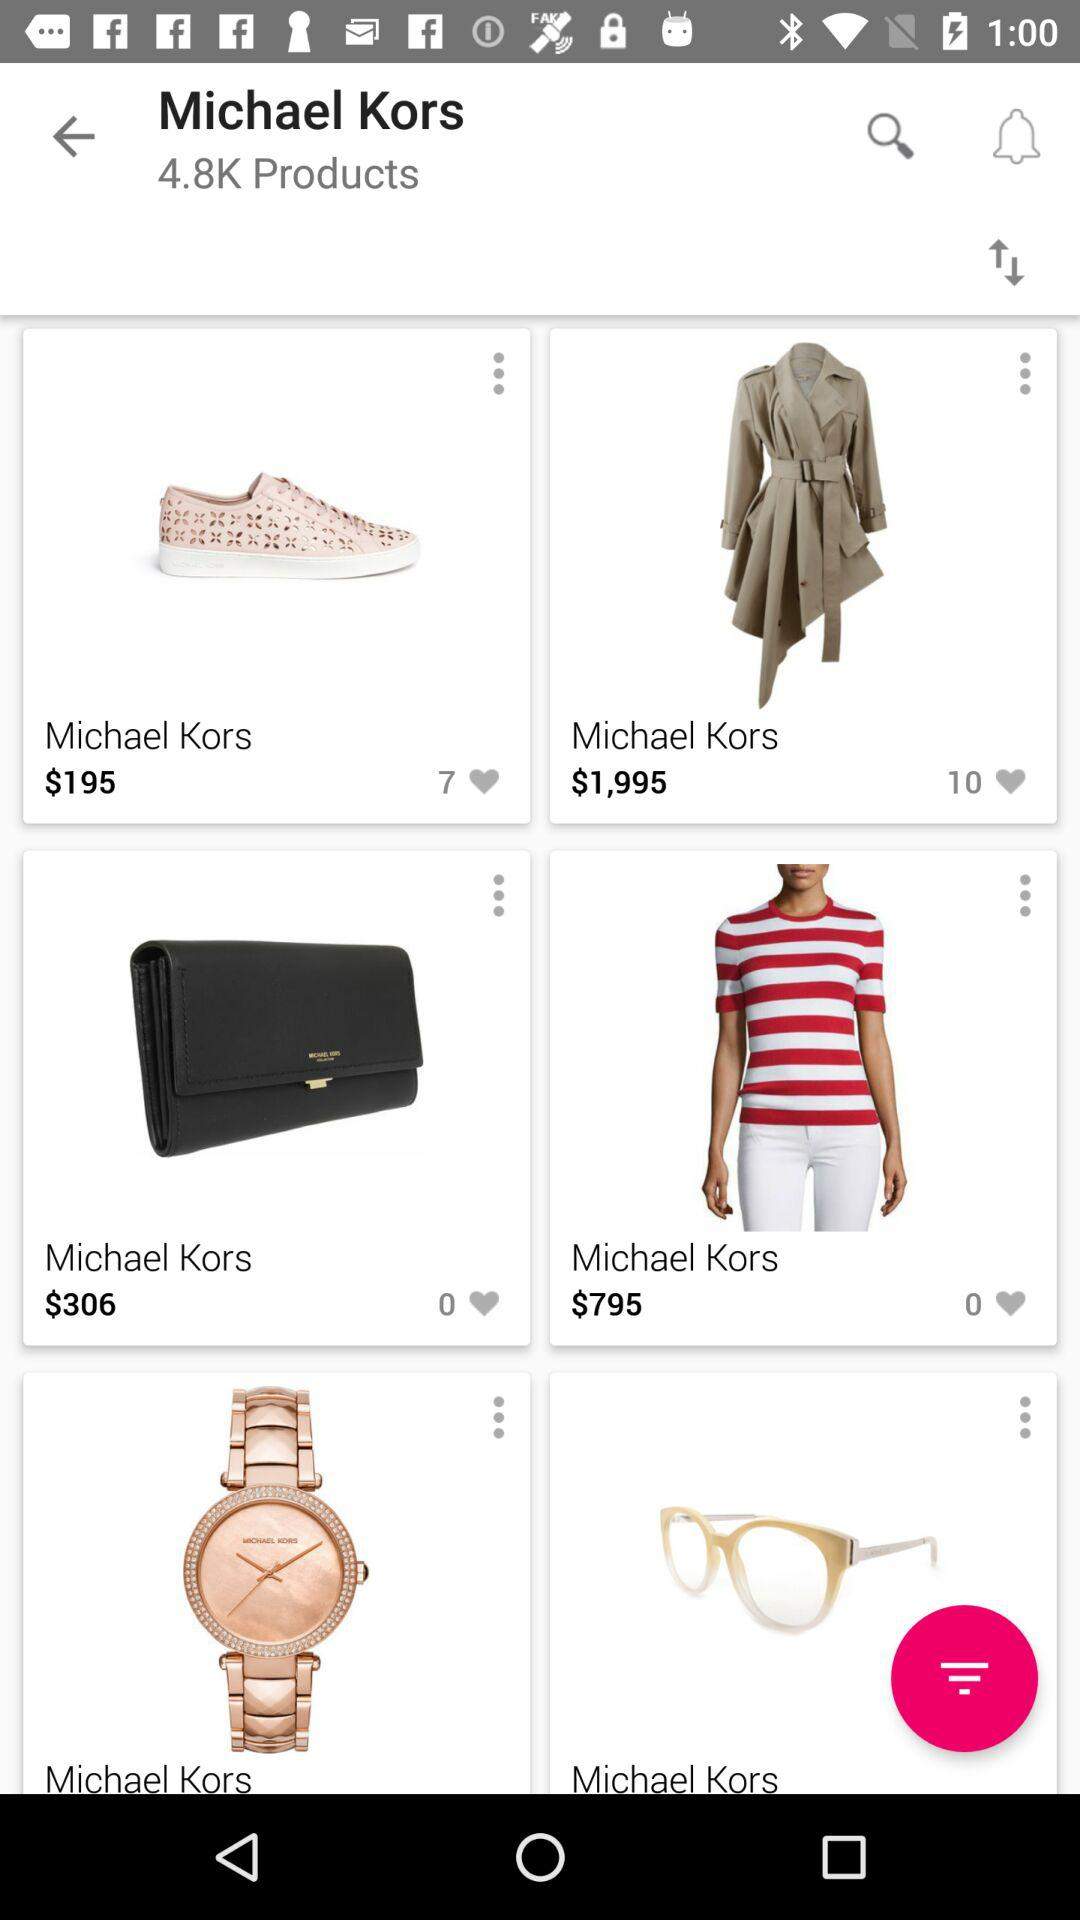What is the price of the shoes? The price is $195. 